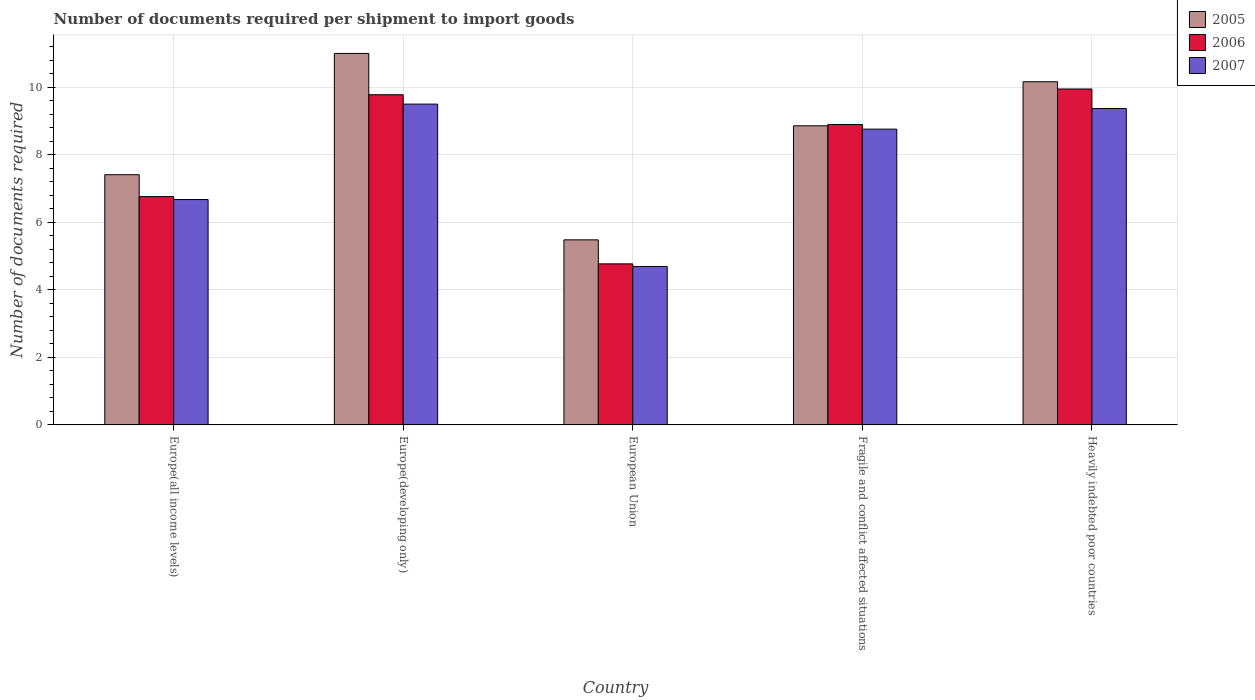How many different coloured bars are there?
Offer a very short reply. 3. How many groups of bars are there?
Make the answer very short. 5. Are the number of bars per tick equal to the number of legend labels?
Your answer should be compact. Yes. How many bars are there on the 1st tick from the left?
Ensure brevity in your answer.  3. How many bars are there on the 2nd tick from the right?
Keep it short and to the point. 3. What is the label of the 1st group of bars from the left?
Your answer should be compact. Europe(all income levels). In how many cases, is the number of bars for a given country not equal to the number of legend labels?
Make the answer very short. 0. What is the number of documents required per shipment to import goods in 2005 in European Union?
Provide a short and direct response. 5.48. Across all countries, what is the minimum number of documents required per shipment to import goods in 2007?
Your answer should be compact. 4.69. In which country was the number of documents required per shipment to import goods in 2007 maximum?
Your response must be concise. Europe(developing only). In which country was the number of documents required per shipment to import goods in 2006 minimum?
Your answer should be very brief. European Union. What is the total number of documents required per shipment to import goods in 2005 in the graph?
Offer a terse response. 42.91. What is the difference between the number of documents required per shipment to import goods in 2007 in Europe(all income levels) and that in Fragile and conflict affected situations?
Provide a succinct answer. -2.08. What is the difference between the number of documents required per shipment to import goods in 2007 in European Union and the number of documents required per shipment to import goods in 2005 in Fragile and conflict affected situations?
Provide a short and direct response. -4.16. What is the average number of documents required per shipment to import goods in 2006 per country?
Offer a terse response. 8.03. What is the difference between the number of documents required per shipment to import goods of/in 2007 and number of documents required per shipment to import goods of/in 2005 in Europe(all income levels)?
Your answer should be compact. -0.74. In how many countries, is the number of documents required per shipment to import goods in 2005 greater than 6.4?
Your answer should be compact. 4. What is the ratio of the number of documents required per shipment to import goods in 2006 in Europe(developing only) to that in European Union?
Your answer should be very brief. 2.05. What is the difference between the highest and the second highest number of documents required per shipment to import goods in 2005?
Keep it short and to the point. -1.31. What is the difference between the highest and the lowest number of documents required per shipment to import goods in 2005?
Your answer should be very brief. 5.52. What does the 2nd bar from the left in Europe(developing only) represents?
Provide a short and direct response. 2006. Are all the bars in the graph horizontal?
Ensure brevity in your answer.  No. What is the difference between two consecutive major ticks on the Y-axis?
Keep it short and to the point. 2. Where does the legend appear in the graph?
Keep it short and to the point. Top right. How many legend labels are there?
Make the answer very short. 3. What is the title of the graph?
Your answer should be compact. Number of documents required per shipment to import goods. What is the label or title of the X-axis?
Keep it short and to the point. Country. What is the label or title of the Y-axis?
Ensure brevity in your answer.  Number of documents required. What is the Number of documents required of 2005 in Europe(all income levels)?
Your answer should be compact. 7.41. What is the Number of documents required of 2006 in Europe(all income levels)?
Provide a short and direct response. 6.76. What is the Number of documents required of 2007 in Europe(all income levels)?
Provide a succinct answer. 6.67. What is the Number of documents required of 2005 in Europe(developing only)?
Ensure brevity in your answer.  11. What is the Number of documents required of 2006 in Europe(developing only)?
Keep it short and to the point. 9.78. What is the Number of documents required of 2005 in European Union?
Provide a short and direct response. 5.48. What is the Number of documents required in 2006 in European Union?
Ensure brevity in your answer.  4.77. What is the Number of documents required of 2007 in European Union?
Offer a very short reply. 4.69. What is the Number of documents required in 2005 in Fragile and conflict affected situations?
Keep it short and to the point. 8.86. What is the Number of documents required in 2006 in Fragile and conflict affected situations?
Offer a terse response. 8.9. What is the Number of documents required of 2007 in Fragile and conflict affected situations?
Give a very brief answer. 8.76. What is the Number of documents required in 2005 in Heavily indebted poor countries?
Give a very brief answer. 10.16. What is the Number of documents required of 2006 in Heavily indebted poor countries?
Make the answer very short. 9.95. What is the Number of documents required in 2007 in Heavily indebted poor countries?
Make the answer very short. 9.37. Across all countries, what is the maximum Number of documents required in 2006?
Offer a very short reply. 9.95. Across all countries, what is the minimum Number of documents required of 2005?
Offer a terse response. 5.48. Across all countries, what is the minimum Number of documents required in 2006?
Give a very brief answer. 4.77. Across all countries, what is the minimum Number of documents required of 2007?
Make the answer very short. 4.69. What is the total Number of documents required of 2005 in the graph?
Offer a terse response. 42.91. What is the total Number of documents required of 2006 in the graph?
Keep it short and to the point. 40.15. What is the total Number of documents required of 2007 in the graph?
Offer a very short reply. 38.99. What is the difference between the Number of documents required in 2005 in Europe(all income levels) and that in Europe(developing only)?
Make the answer very short. -3.59. What is the difference between the Number of documents required in 2006 in Europe(all income levels) and that in Europe(developing only)?
Provide a succinct answer. -3.02. What is the difference between the Number of documents required in 2007 in Europe(all income levels) and that in Europe(developing only)?
Offer a very short reply. -2.83. What is the difference between the Number of documents required in 2005 in Europe(all income levels) and that in European Union?
Your response must be concise. 1.93. What is the difference between the Number of documents required in 2006 in Europe(all income levels) and that in European Union?
Your response must be concise. 1.99. What is the difference between the Number of documents required in 2007 in Europe(all income levels) and that in European Union?
Offer a terse response. 1.98. What is the difference between the Number of documents required in 2005 in Europe(all income levels) and that in Fragile and conflict affected situations?
Ensure brevity in your answer.  -1.45. What is the difference between the Number of documents required of 2006 in Europe(all income levels) and that in Fragile and conflict affected situations?
Keep it short and to the point. -2.14. What is the difference between the Number of documents required in 2007 in Europe(all income levels) and that in Fragile and conflict affected situations?
Make the answer very short. -2.08. What is the difference between the Number of documents required of 2005 in Europe(all income levels) and that in Heavily indebted poor countries?
Make the answer very short. -2.75. What is the difference between the Number of documents required in 2006 in Europe(all income levels) and that in Heavily indebted poor countries?
Offer a terse response. -3.19. What is the difference between the Number of documents required in 2007 in Europe(all income levels) and that in Heavily indebted poor countries?
Make the answer very short. -2.69. What is the difference between the Number of documents required in 2005 in Europe(developing only) and that in European Union?
Your answer should be very brief. 5.52. What is the difference between the Number of documents required of 2006 in Europe(developing only) and that in European Union?
Your response must be concise. 5.01. What is the difference between the Number of documents required of 2007 in Europe(developing only) and that in European Union?
Keep it short and to the point. 4.81. What is the difference between the Number of documents required in 2005 in Europe(developing only) and that in Fragile and conflict affected situations?
Provide a succinct answer. 2.14. What is the difference between the Number of documents required in 2006 in Europe(developing only) and that in Fragile and conflict affected situations?
Offer a very short reply. 0.88. What is the difference between the Number of documents required of 2007 in Europe(developing only) and that in Fragile and conflict affected situations?
Your answer should be compact. 0.74. What is the difference between the Number of documents required of 2005 in Europe(developing only) and that in Heavily indebted poor countries?
Your answer should be compact. 0.84. What is the difference between the Number of documents required of 2006 in Europe(developing only) and that in Heavily indebted poor countries?
Your answer should be compact. -0.17. What is the difference between the Number of documents required of 2007 in Europe(developing only) and that in Heavily indebted poor countries?
Offer a very short reply. 0.13. What is the difference between the Number of documents required of 2005 in European Union and that in Fragile and conflict affected situations?
Provide a short and direct response. -3.38. What is the difference between the Number of documents required in 2006 in European Union and that in Fragile and conflict affected situations?
Offer a very short reply. -4.13. What is the difference between the Number of documents required in 2007 in European Union and that in Fragile and conflict affected situations?
Your response must be concise. -4.07. What is the difference between the Number of documents required in 2005 in European Union and that in Heavily indebted poor countries?
Ensure brevity in your answer.  -4.68. What is the difference between the Number of documents required of 2006 in European Union and that in Heavily indebted poor countries?
Give a very brief answer. -5.18. What is the difference between the Number of documents required of 2007 in European Union and that in Heavily indebted poor countries?
Your answer should be compact. -4.68. What is the difference between the Number of documents required of 2005 in Fragile and conflict affected situations and that in Heavily indebted poor countries?
Your answer should be very brief. -1.3. What is the difference between the Number of documents required in 2006 in Fragile and conflict affected situations and that in Heavily indebted poor countries?
Provide a succinct answer. -1.05. What is the difference between the Number of documents required of 2007 in Fragile and conflict affected situations and that in Heavily indebted poor countries?
Your answer should be compact. -0.61. What is the difference between the Number of documents required of 2005 in Europe(all income levels) and the Number of documents required of 2006 in Europe(developing only)?
Give a very brief answer. -2.37. What is the difference between the Number of documents required of 2005 in Europe(all income levels) and the Number of documents required of 2007 in Europe(developing only)?
Make the answer very short. -2.09. What is the difference between the Number of documents required of 2006 in Europe(all income levels) and the Number of documents required of 2007 in Europe(developing only)?
Offer a very short reply. -2.74. What is the difference between the Number of documents required of 2005 in Europe(all income levels) and the Number of documents required of 2006 in European Union?
Offer a very short reply. 2.64. What is the difference between the Number of documents required of 2005 in Europe(all income levels) and the Number of documents required of 2007 in European Union?
Offer a terse response. 2.72. What is the difference between the Number of documents required of 2006 in Europe(all income levels) and the Number of documents required of 2007 in European Union?
Offer a very short reply. 2.07. What is the difference between the Number of documents required in 2005 in Europe(all income levels) and the Number of documents required in 2006 in Fragile and conflict affected situations?
Give a very brief answer. -1.49. What is the difference between the Number of documents required in 2005 in Europe(all income levels) and the Number of documents required in 2007 in Fragile and conflict affected situations?
Provide a short and direct response. -1.35. What is the difference between the Number of documents required of 2006 in Europe(all income levels) and the Number of documents required of 2007 in Fragile and conflict affected situations?
Offer a terse response. -2. What is the difference between the Number of documents required of 2005 in Europe(all income levels) and the Number of documents required of 2006 in Heavily indebted poor countries?
Ensure brevity in your answer.  -2.54. What is the difference between the Number of documents required of 2005 in Europe(all income levels) and the Number of documents required of 2007 in Heavily indebted poor countries?
Your answer should be very brief. -1.96. What is the difference between the Number of documents required in 2006 in Europe(all income levels) and the Number of documents required in 2007 in Heavily indebted poor countries?
Your answer should be compact. -2.61. What is the difference between the Number of documents required in 2005 in Europe(developing only) and the Number of documents required in 2006 in European Union?
Offer a terse response. 6.23. What is the difference between the Number of documents required in 2005 in Europe(developing only) and the Number of documents required in 2007 in European Union?
Ensure brevity in your answer.  6.31. What is the difference between the Number of documents required in 2006 in Europe(developing only) and the Number of documents required in 2007 in European Union?
Make the answer very short. 5.09. What is the difference between the Number of documents required in 2005 in Europe(developing only) and the Number of documents required in 2006 in Fragile and conflict affected situations?
Provide a succinct answer. 2.1. What is the difference between the Number of documents required of 2005 in Europe(developing only) and the Number of documents required of 2007 in Fragile and conflict affected situations?
Offer a very short reply. 2.24. What is the difference between the Number of documents required of 2006 in Europe(developing only) and the Number of documents required of 2007 in Fragile and conflict affected situations?
Offer a terse response. 1.02. What is the difference between the Number of documents required in 2005 in Europe(developing only) and the Number of documents required in 2006 in Heavily indebted poor countries?
Provide a short and direct response. 1.05. What is the difference between the Number of documents required of 2005 in Europe(developing only) and the Number of documents required of 2007 in Heavily indebted poor countries?
Make the answer very short. 1.63. What is the difference between the Number of documents required in 2006 in Europe(developing only) and the Number of documents required in 2007 in Heavily indebted poor countries?
Your response must be concise. 0.41. What is the difference between the Number of documents required of 2005 in European Union and the Number of documents required of 2006 in Fragile and conflict affected situations?
Give a very brief answer. -3.42. What is the difference between the Number of documents required of 2005 in European Union and the Number of documents required of 2007 in Fragile and conflict affected situations?
Offer a terse response. -3.28. What is the difference between the Number of documents required of 2006 in European Union and the Number of documents required of 2007 in Fragile and conflict affected situations?
Your response must be concise. -3.99. What is the difference between the Number of documents required in 2005 in European Union and the Number of documents required in 2006 in Heavily indebted poor countries?
Offer a terse response. -4.47. What is the difference between the Number of documents required of 2005 in European Union and the Number of documents required of 2007 in Heavily indebted poor countries?
Your response must be concise. -3.89. What is the difference between the Number of documents required of 2006 in European Union and the Number of documents required of 2007 in Heavily indebted poor countries?
Your answer should be compact. -4.6. What is the difference between the Number of documents required of 2005 in Fragile and conflict affected situations and the Number of documents required of 2006 in Heavily indebted poor countries?
Offer a terse response. -1.09. What is the difference between the Number of documents required in 2005 in Fragile and conflict affected situations and the Number of documents required in 2007 in Heavily indebted poor countries?
Make the answer very short. -0.51. What is the difference between the Number of documents required of 2006 in Fragile and conflict affected situations and the Number of documents required of 2007 in Heavily indebted poor countries?
Your response must be concise. -0.47. What is the average Number of documents required in 2005 per country?
Ensure brevity in your answer.  8.58. What is the average Number of documents required of 2006 per country?
Ensure brevity in your answer.  8.03. What is the average Number of documents required in 2007 per country?
Keep it short and to the point. 7.8. What is the difference between the Number of documents required of 2005 and Number of documents required of 2006 in Europe(all income levels)?
Keep it short and to the point. 0.65. What is the difference between the Number of documents required in 2005 and Number of documents required in 2007 in Europe(all income levels)?
Provide a succinct answer. 0.74. What is the difference between the Number of documents required in 2006 and Number of documents required in 2007 in Europe(all income levels)?
Make the answer very short. 0.09. What is the difference between the Number of documents required in 2005 and Number of documents required in 2006 in Europe(developing only)?
Provide a succinct answer. 1.22. What is the difference between the Number of documents required in 2005 and Number of documents required in 2007 in Europe(developing only)?
Your answer should be compact. 1.5. What is the difference between the Number of documents required of 2006 and Number of documents required of 2007 in Europe(developing only)?
Ensure brevity in your answer.  0.28. What is the difference between the Number of documents required of 2005 and Number of documents required of 2006 in European Union?
Your response must be concise. 0.71. What is the difference between the Number of documents required of 2005 and Number of documents required of 2007 in European Union?
Provide a succinct answer. 0.79. What is the difference between the Number of documents required in 2006 and Number of documents required in 2007 in European Union?
Provide a short and direct response. 0.08. What is the difference between the Number of documents required of 2005 and Number of documents required of 2006 in Fragile and conflict affected situations?
Your answer should be compact. -0.04. What is the difference between the Number of documents required of 2005 and Number of documents required of 2007 in Fragile and conflict affected situations?
Your response must be concise. 0.1. What is the difference between the Number of documents required of 2006 and Number of documents required of 2007 in Fragile and conflict affected situations?
Offer a terse response. 0.14. What is the difference between the Number of documents required in 2005 and Number of documents required in 2006 in Heavily indebted poor countries?
Your answer should be very brief. 0.21. What is the difference between the Number of documents required in 2005 and Number of documents required in 2007 in Heavily indebted poor countries?
Offer a very short reply. 0.79. What is the difference between the Number of documents required of 2006 and Number of documents required of 2007 in Heavily indebted poor countries?
Ensure brevity in your answer.  0.58. What is the ratio of the Number of documents required in 2005 in Europe(all income levels) to that in Europe(developing only)?
Offer a terse response. 0.67. What is the ratio of the Number of documents required of 2006 in Europe(all income levels) to that in Europe(developing only)?
Keep it short and to the point. 0.69. What is the ratio of the Number of documents required in 2007 in Europe(all income levels) to that in Europe(developing only)?
Make the answer very short. 0.7. What is the ratio of the Number of documents required of 2005 in Europe(all income levels) to that in European Union?
Provide a short and direct response. 1.35. What is the ratio of the Number of documents required of 2006 in Europe(all income levels) to that in European Union?
Make the answer very short. 1.42. What is the ratio of the Number of documents required of 2007 in Europe(all income levels) to that in European Union?
Offer a terse response. 1.42. What is the ratio of the Number of documents required in 2005 in Europe(all income levels) to that in Fragile and conflict affected situations?
Provide a succinct answer. 0.84. What is the ratio of the Number of documents required in 2006 in Europe(all income levels) to that in Fragile and conflict affected situations?
Give a very brief answer. 0.76. What is the ratio of the Number of documents required in 2007 in Europe(all income levels) to that in Fragile and conflict affected situations?
Give a very brief answer. 0.76. What is the ratio of the Number of documents required in 2005 in Europe(all income levels) to that in Heavily indebted poor countries?
Offer a very short reply. 0.73. What is the ratio of the Number of documents required in 2006 in Europe(all income levels) to that in Heavily indebted poor countries?
Your answer should be very brief. 0.68. What is the ratio of the Number of documents required in 2007 in Europe(all income levels) to that in Heavily indebted poor countries?
Give a very brief answer. 0.71. What is the ratio of the Number of documents required in 2005 in Europe(developing only) to that in European Union?
Keep it short and to the point. 2.01. What is the ratio of the Number of documents required of 2006 in Europe(developing only) to that in European Union?
Your answer should be compact. 2.05. What is the ratio of the Number of documents required in 2007 in Europe(developing only) to that in European Union?
Provide a succinct answer. 2.02. What is the ratio of the Number of documents required of 2005 in Europe(developing only) to that in Fragile and conflict affected situations?
Provide a succinct answer. 1.24. What is the ratio of the Number of documents required in 2006 in Europe(developing only) to that in Fragile and conflict affected situations?
Give a very brief answer. 1.1. What is the ratio of the Number of documents required in 2007 in Europe(developing only) to that in Fragile and conflict affected situations?
Your answer should be very brief. 1.08. What is the ratio of the Number of documents required in 2005 in Europe(developing only) to that in Heavily indebted poor countries?
Your answer should be compact. 1.08. What is the ratio of the Number of documents required of 2007 in Europe(developing only) to that in Heavily indebted poor countries?
Ensure brevity in your answer.  1.01. What is the ratio of the Number of documents required of 2005 in European Union to that in Fragile and conflict affected situations?
Keep it short and to the point. 0.62. What is the ratio of the Number of documents required in 2006 in European Union to that in Fragile and conflict affected situations?
Make the answer very short. 0.54. What is the ratio of the Number of documents required of 2007 in European Union to that in Fragile and conflict affected situations?
Offer a terse response. 0.54. What is the ratio of the Number of documents required of 2005 in European Union to that in Heavily indebted poor countries?
Provide a short and direct response. 0.54. What is the ratio of the Number of documents required of 2006 in European Union to that in Heavily indebted poor countries?
Your answer should be compact. 0.48. What is the ratio of the Number of documents required in 2007 in European Union to that in Heavily indebted poor countries?
Your answer should be compact. 0.5. What is the ratio of the Number of documents required of 2005 in Fragile and conflict affected situations to that in Heavily indebted poor countries?
Your response must be concise. 0.87. What is the ratio of the Number of documents required in 2006 in Fragile and conflict affected situations to that in Heavily indebted poor countries?
Keep it short and to the point. 0.89. What is the ratio of the Number of documents required in 2007 in Fragile and conflict affected situations to that in Heavily indebted poor countries?
Provide a succinct answer. 0.93. What is the difference between the highest and the second highest Number of documents required in 2005?
Provide a short and direct response. 0.84. What is the difference between the highest and the second highest Number of documents required in 2006?
Your answer should be very brief. 0.17. What is the difference between the highest and the second highest Number of documents required in 2007?
Offer a very short reply. 0.13. What is the difference between the highest and the lowest Number of documents required in 2005?
Your response must be concise. 5.52. What is the difference between the highest and the lowest Number of documents required of 2006?
Offer a terse response. 5.18. What is the difference between the highest and the lowest Number of documents required in 2007?
Make the answer very short. 4.81. 